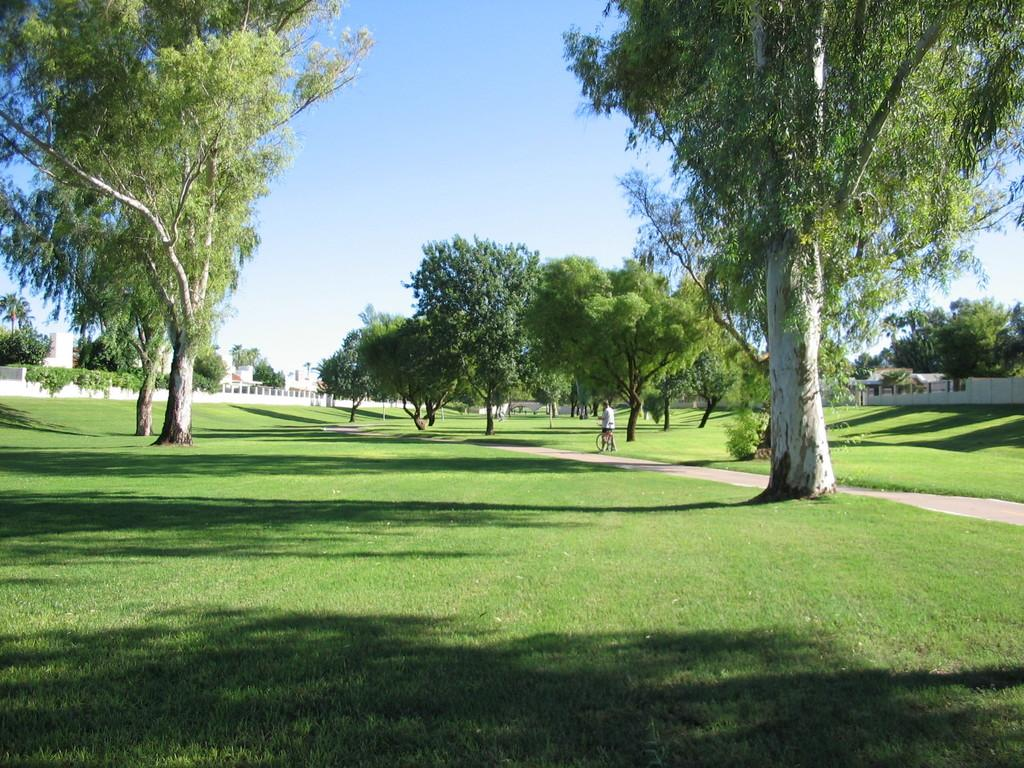What type of terrain is visible in the image? There is grass on the ground in the image. What other natural elements can be seen in the image? There are trees in the image. What is the person in the image doing? There is a person on a cycle in the image. What can be seen in the background of the image? There are buildings and walls in the background of the image. What part of the natural environment is visible in the image? The sky is visible in the image. What type of punishment system is depicted in the image? There is no punishment system present in the image; it features grass, trees, a person on a cycle, buildings, walls, and the sky. What type of produce is being harvested in the image? There is no produce being harvested in the image; it features grass, trees, a person on a cycle, buildings, walls, and the sky. 